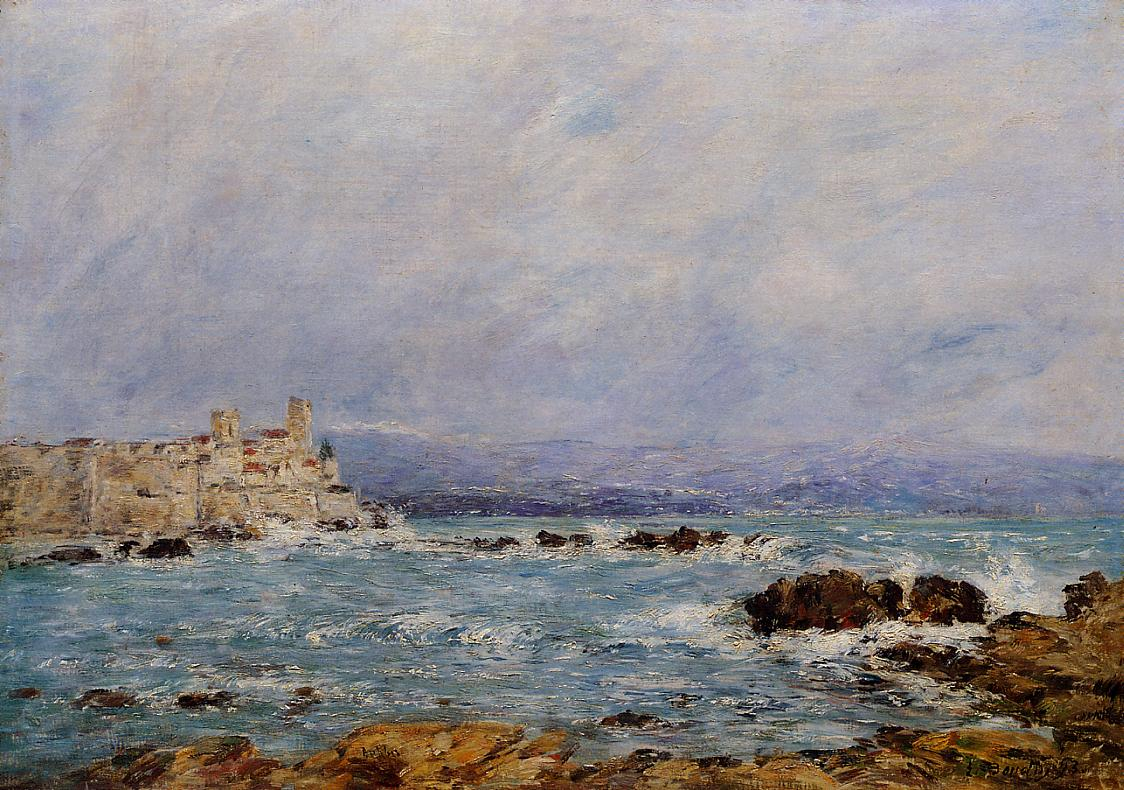Imagine the castle is inhabited. Who lives there and what is their story? Inhabitants of the castle include a reclusive artist family who draw inspiration from the seaside splendor. Over generations, they have decorated the walls with masterful paintings, each capturing different moods of the landscape. Their legacy is intertwined with tales of a painter who once fell in love with a mermaid, believing the sea held magical muses. Each family member strives to capture the ocean's ever-changing beauty, believing their artistry maintains the castle's enchantment and connection to the mysterious sea. 